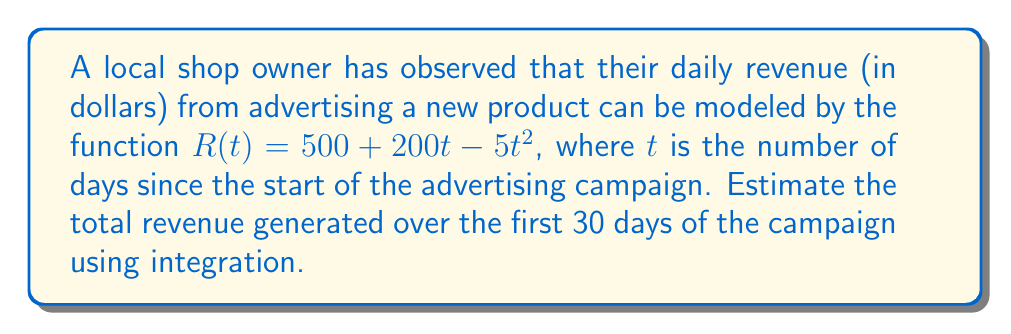Could you help me with this problem? To estimate the total revenue over the 30-day period, we need to integrate the revenue function $R(t)$ from $t=0$ to $t=30$. This will give us the area under the revenue curve, which represents the total revenue.

Step 1: Set up the definite integral
$$\text{Total Revenue} = \int_0^{30} R(t) dt = \int_0^{30} (500 + 200t - 5t^2) dt$$

Step 2: Integrate the function
$$\int_0^{30} (500 + 200t - 5t^2) dt = \left[500t + 100t^2 - \frac{5}{3}t^3\right]_0^{30}$$

Step 3: Evaluate the integral at the bounds
$$= \left(500(30) + 100(30)^2 - \frac{5}{3}(30)^3\right) - \left(500(0) + 100(0)^2 - \frac{5}{3}(0)^3\right)$$
$$= \left(15000 + 90000 - 4500\right) - 0$$
$$= 100500$$

Therefore, the estimated total revenue over the 30-day period is $100,500.
Answer: $100,500 